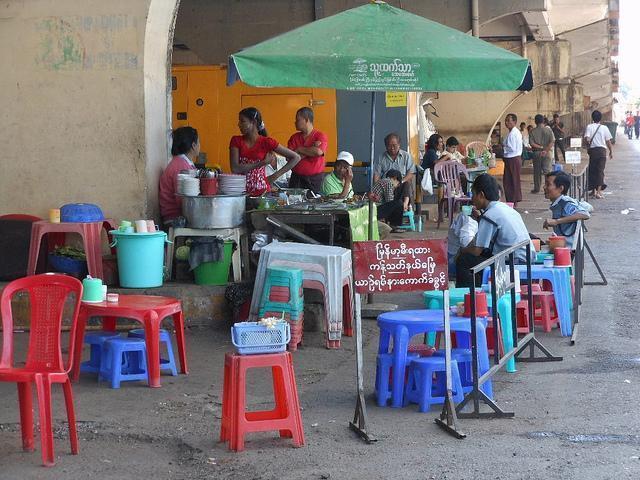What are the colored plastic objects for?
Choose the right answer and clarify with the format: 'Answer: answer
Rationale: rationale.'
Options: Sitting, hold food, for sale, stacking. Answer: sitting.
Rationale: Some of the colored plastic objects are in use and they have features consistent with answer a. 